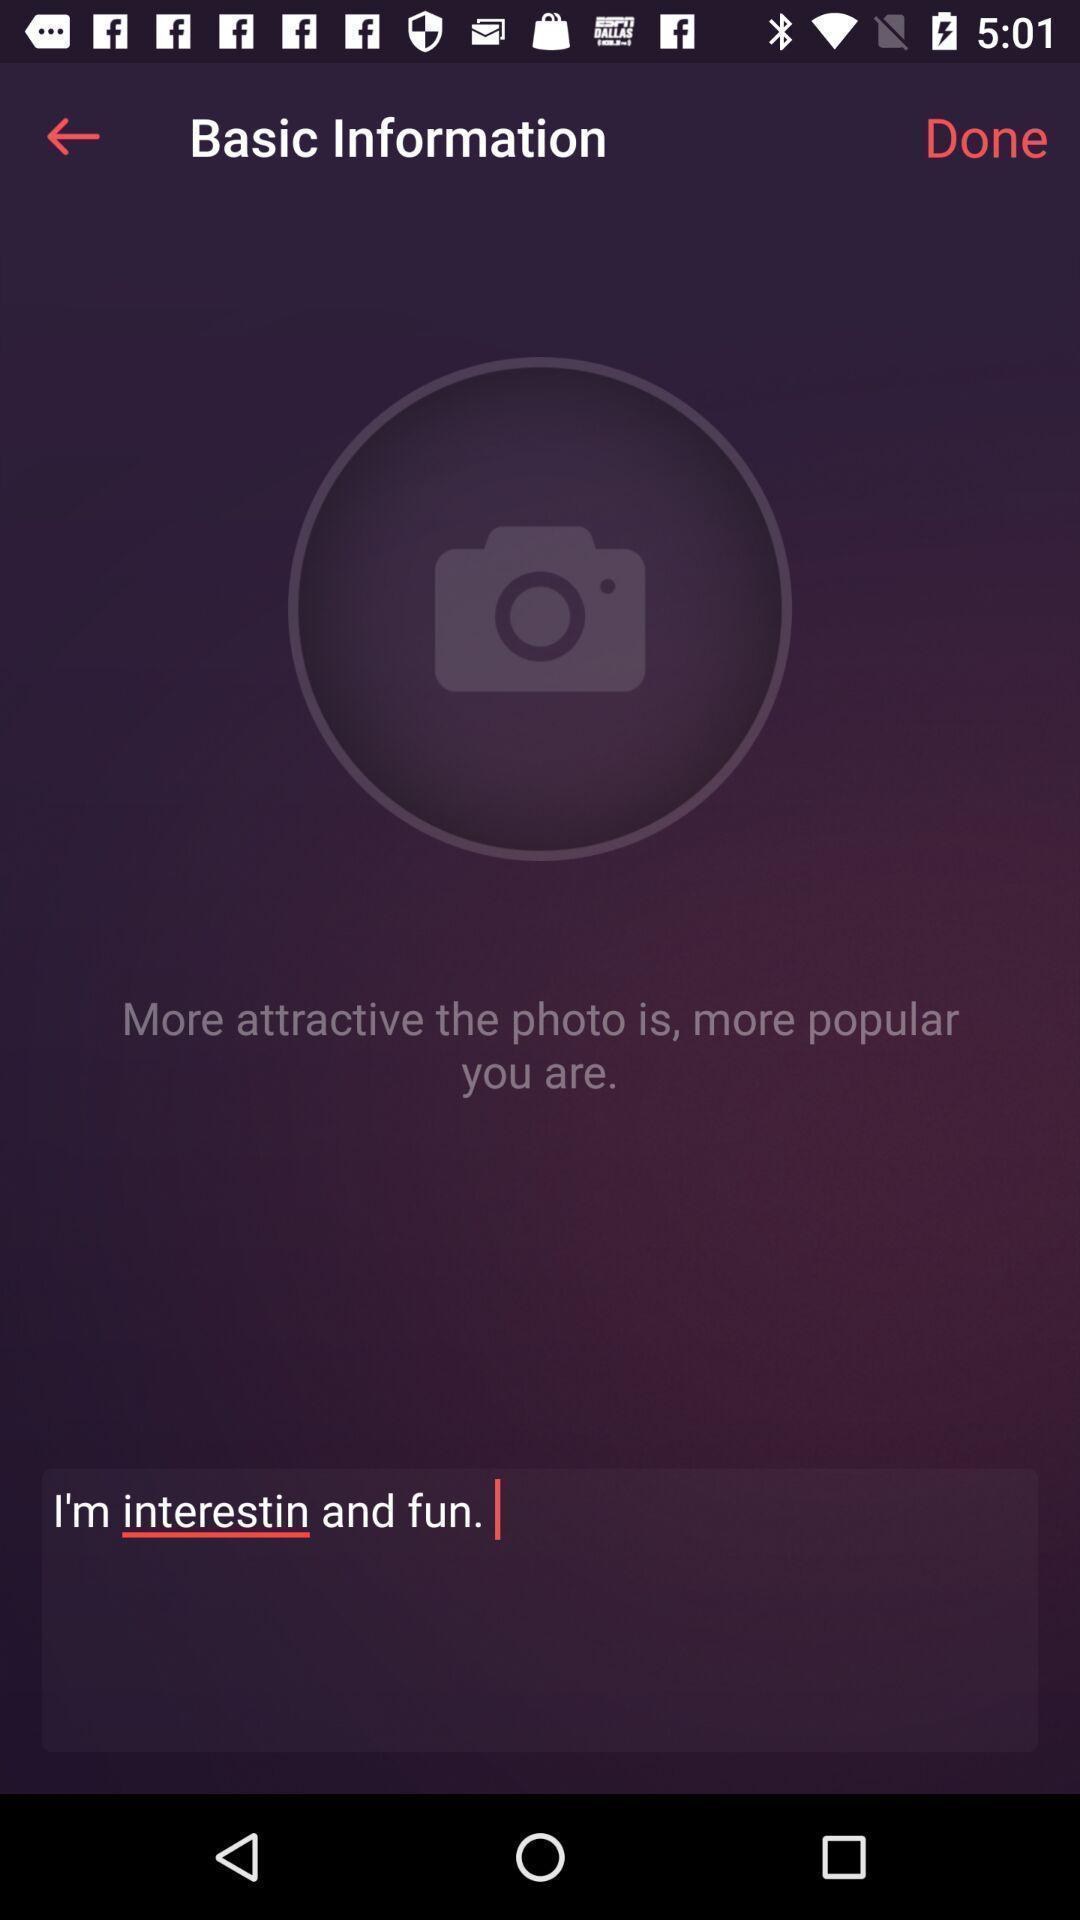Summarize the information in this screenshot. Screen showing basic information page. 